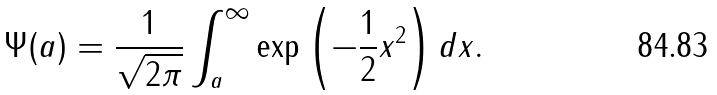<formula> <loc_0><loc_0><loc_500><loc_500>\Psi ( a ) = \frac { 1 } { \sqrt { 2 \pi } } \int _ { a } ^ { \infty } \exp \left ( - \frac { 1 } { 2 } x ^ { 2 } \right ) d x .</formula> 